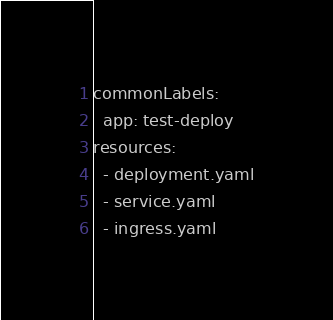Convert code to text. <code><loc_0><loc_0><loc_500><loc_500><_YAML_>commonLabels:
  app: test-deploy
resources:
  - deployment.yaml
  - service.yaml
  - ingress.yaml</code> 